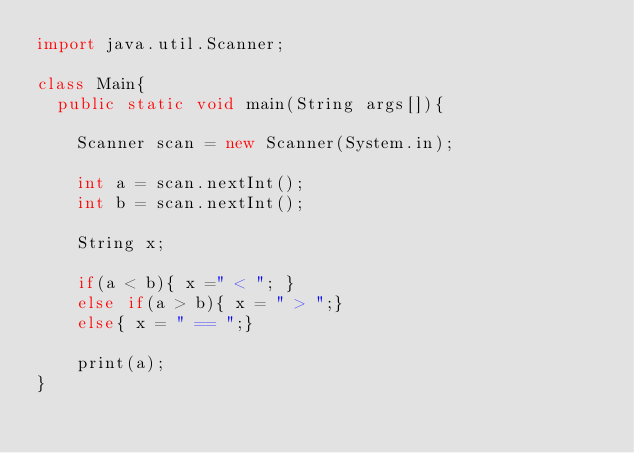<code> <loc_0><loc_0><loc_500><loc_500><_Java_>import java.util.Scanner;

class Main{
  public static void main(String args[]){

    Scanner scan = new Scanner(System.in);

    int a = scan.nextInt();
    int b = scan.nextInt();

    String x;
    
    if(a < b){ x =" < "; }
    else if(a > b){ x = " > ";}
    else{ x = " == ";}

    print(a);
}</code> 